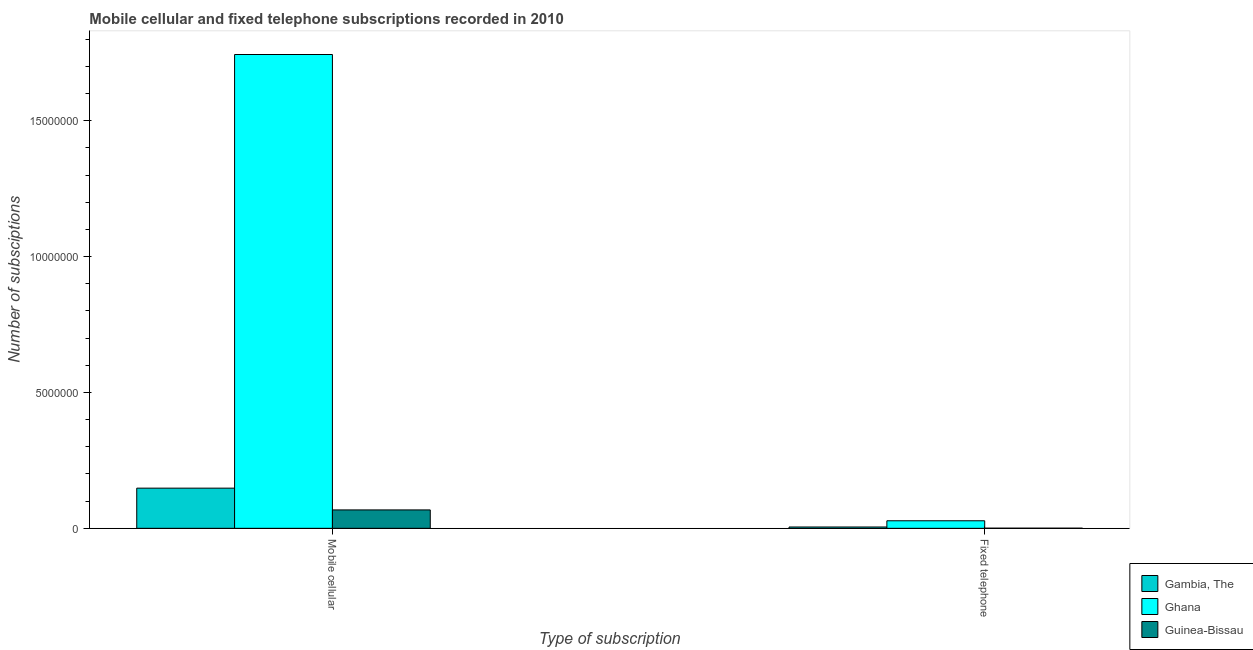How many groups of bars are there?
Provide a short and direct response. 2. How many bars are there on the 1st tick from the right?
Ensure brevity in your answer.  3. What is the label of the 1st group of bars from the left?
Provide a short and direct response. Mobile cellular. What is the number of mobile cellular subscriptions in Gambia, The?
Make the answer very short. 1.48e+06. Across all countries, what is the maximum number of fixed telephone subscriptions?
Make the answer very short. 2.78e+05. Across all countries, what is the minimum number of fixed telephone subscriptions?
Provide a succinct answer. 5000. In which country was the number of mobile cellular subscriptions minimum?
Give a very brief answer. Guinea-Bissau. What is the total number of fixed telephone subscriptions in the graph?
Offer a very short reply. 3.32e+05. What is the difference between the number of fixed telephone subscriptions in Ghana and that in Gambia, The?
Offer a terse response. 2.29e+05. What is the difference between the number of mobile cellular subscriptions in Ghana and the number of fixed telephone subscriptions in Guinea-Bissau?
Your answer should be very brief. 1.74e+07. What is the average number of mobile cellular subscriptions per country?
Make the answer very short. 6.53e+06. What is the difference between the number of fixed telephone subscriptions and number of mobile cellular subscriptions in Guinea-Bissau?
Your answer should be compact. -6.72e+05. What is the ratio of the number of mobile cellular subscriptions in Ghana to that in Guinea-Bissau?
Give a very brief answer. 25.74. Is the number of mobile cellular subscriptions in Gambia, The less than that in Ghana?
Offer a terse response. Yes. In how many countries, is the number of fixed telephone subscriptions greater than the average number of fixed telephone subscriptions taken over all countries?
Your answer should be compact. 1. What does the 3rd bar from the left in Fixed telephone represents?
Ensure brevity in your answer.  Guinea-Bissau. What does the 3rd bar from the right in Fixed telephone represents?
Offer a very short reply. Gambia, The. How many bars are there?
Give a very brief answer. 6. What is the difference between two consecutive major ticks on the Y-axis?
Offer a very short reply. 5.00e+06. Does the graph contain any zero values?
Provide a short and direct response. No. Does the graph contain grids?
Provide a short and direct response. No. How are the legend labels stacked?
Your response must be concise. Vertical. What is the title of the graph?
Offer a very short reply. Mobile cellular and fixed telephone subscriptions recorded in 2010. What is the label or title of the X-axis?
Your answer should be very brief. Type of subscription. What is the label or title of the Y-axis?
Ensure brevity in your answer.  Number of subsciptions. What is the Number of subsciptions in Gambia, The in Mobile cellular?
Keep it short and to the point. 1.48e+06. What is the Number of subsciptions of Ghana in Mobile cellular?
Your response must be concise. 1.74e+07. What is the Number of subsciptions in Guinea-Bissau in Mobile cellular?
Give a very brief answer. 6.77e+05. What is the Number of subsciptions of Gambia, The in Fixed telephone?
Offer a very short reply. 4.88e+04. What is the Number of subsciptions of Ghana in Fixed telephone?
Offer a very short reply. 2.78e+05. Across all Type of subscription, what is the maximum Number of subsciptions of Gambia, The?
Your answer should be very brief. 1.48e+06. Across all Type of subscription, what is the maximum Number of subsciptions of Ghana?
Your answer should be very brief. 1.74e+07. Across all Type of subscription, what is the maximum Number of subsciptions of Guinea-Bissau?
Ensure brevity in your answer.  6.77e+05. Across all Type of subscription, what is the minimum Number of subsciptions of Gambia, The?
Your answer should be compact. 4.88e+04. Across all Type of subscription, what is the minimum Number of subsciptions in Ghana?
Provide a short and direct response. 2.78e+05. Across all Type of subscription, what is the minimum Number of subsciptions of Guinea-Bissau?
Offer a terse response. 5000. What is the total Number of subsciptions of Gambia, The in the graph?
Provide a short and direct response. 1.53e+06. What is the total Number of subsciptions in Ghana in the graph?
Your answer should be very brief. 1.77e+07. What is the total Number of subsciptions of Guinea-Bissau in the graph?
Provide a succinct answer. 6.82e+05. What is the difference between the Number of subsciptions of Gambia, The in Mobile cellular and that in Fixed telephone?
Your answer should be compact. 1.43e+06. What is the difference between the Number of subsciptions in Ghana in Mobile cellular and that in Fixed telephone?
Provide a short and direct response. 1.72e+07. What is the difference between the Number of subsciptions of Guinea-Bissau in Mobile cellular and that in Fixed telephone?
Your answer should be very brief. 6.72e+05. What is the difference between the Number of subsciptions in Gambia, The in Mobile cellular and the Number of subsciptions in Ghana in Fixed telephone?
Your response must be concise. 1.20e+06. What is the difference between the Number of subsciptions of Gambia, The in Mobile cellular and the Number of subsciptions of Guinea-Bissau in Fixed telephone?
Provide a short and direct response. 1.47e+06. What is the difference between the Number of subsciptions of Ghana in Mobile cellular and the Number of subsciptions of Guinea-Bissau in Fixed telephone?
Provide a succinct answer. 1.74e+07. What is the average Number of subsciptions of Gambia, The per Type of subscription?
Your answer should be very brief. 7.64e+05. What is the average Number of subsciptions in Ghana per Type of subscription?
Ensure brevity in your answer.  8.86e+06. What is the average Number of subsciptions in Guinea-Bissau per Type of subscription?
Provide a succinct answer. 3.41e+05. What is the difference between the Number of subsciptions in Gambia, The and Number of subsciptions in Ghana in Mobile cellular?
Ensure brevity in your answer.  -1.60e+07. What is the difference between the Number of subsciptions of Gambia, The and Number of subsciptions of Guinea-Bissau in Mobile cellular?
Offer a very short reply. 8.01e+05. What is the difference between the Number of subsciptions in Ghana and Number of subsciptions in Guinea-Bissau in Mobile cellular?
Provide a short and direct response. 1.68e+07. What is the difference between the Number of subsciptions of Gambia, The and Number of subsciptions of Ghana in Fixed telephone?
Your answer should be compact. -2.29e+05. What is the difference between the Number of subsciptions in Gambia, The and Number of subsciptions in Guinea-Bissau in Fixed telephone?
Ensure brevity in your answer.  4.38e+04. What is the difference between the Number of subsciptions in Ghana and Number of subsciptions in Guinea-Bissau in Fixed telephone?
Your answer should be compact. 2.73e+05. What is the ratio of the Number of subsciptions of Gambia, The in Mobile cellular to that in Fixed telephone?
Make the answer very short. 30.31. What is the ratio of the Number of subsciptions of Ghana in Mobile cellular to that in Fixed telephone?
Give a very brief answer. 62.75. What is the ratio of the Number of subsciptions of Guinea-Bissau in Mobile cellular to that in Fixed telephone?
Offer a very short reply. 135.47. What is the difference between the highest and the second highest Number of subsciptions of Gambia, The?
Give a very brief answer. 1.43e+06. What is the difference between the highest and the second highest Number of subsciptions of Ghana?
Provide a short and direct response. 1.72e+07. What is the difference between the highest and the second highest Number of subsciptions in Guinea-Bissau?
Give a very brief answer. 6.72e+05. What is the difference between the highest and the lowest Number of subsciptions in Gambia, The?
Provide a short and direct response. 1.43e+06. What is the difference between the highest and the lowest Number of subsciptions in Ghana?
Your answer should be compact. 1.72e+07. What is the difference between the highest and the lowest Number of subsciptions in Guinea-Bissau?
Provide a succinct answer. 6.72e+05. 